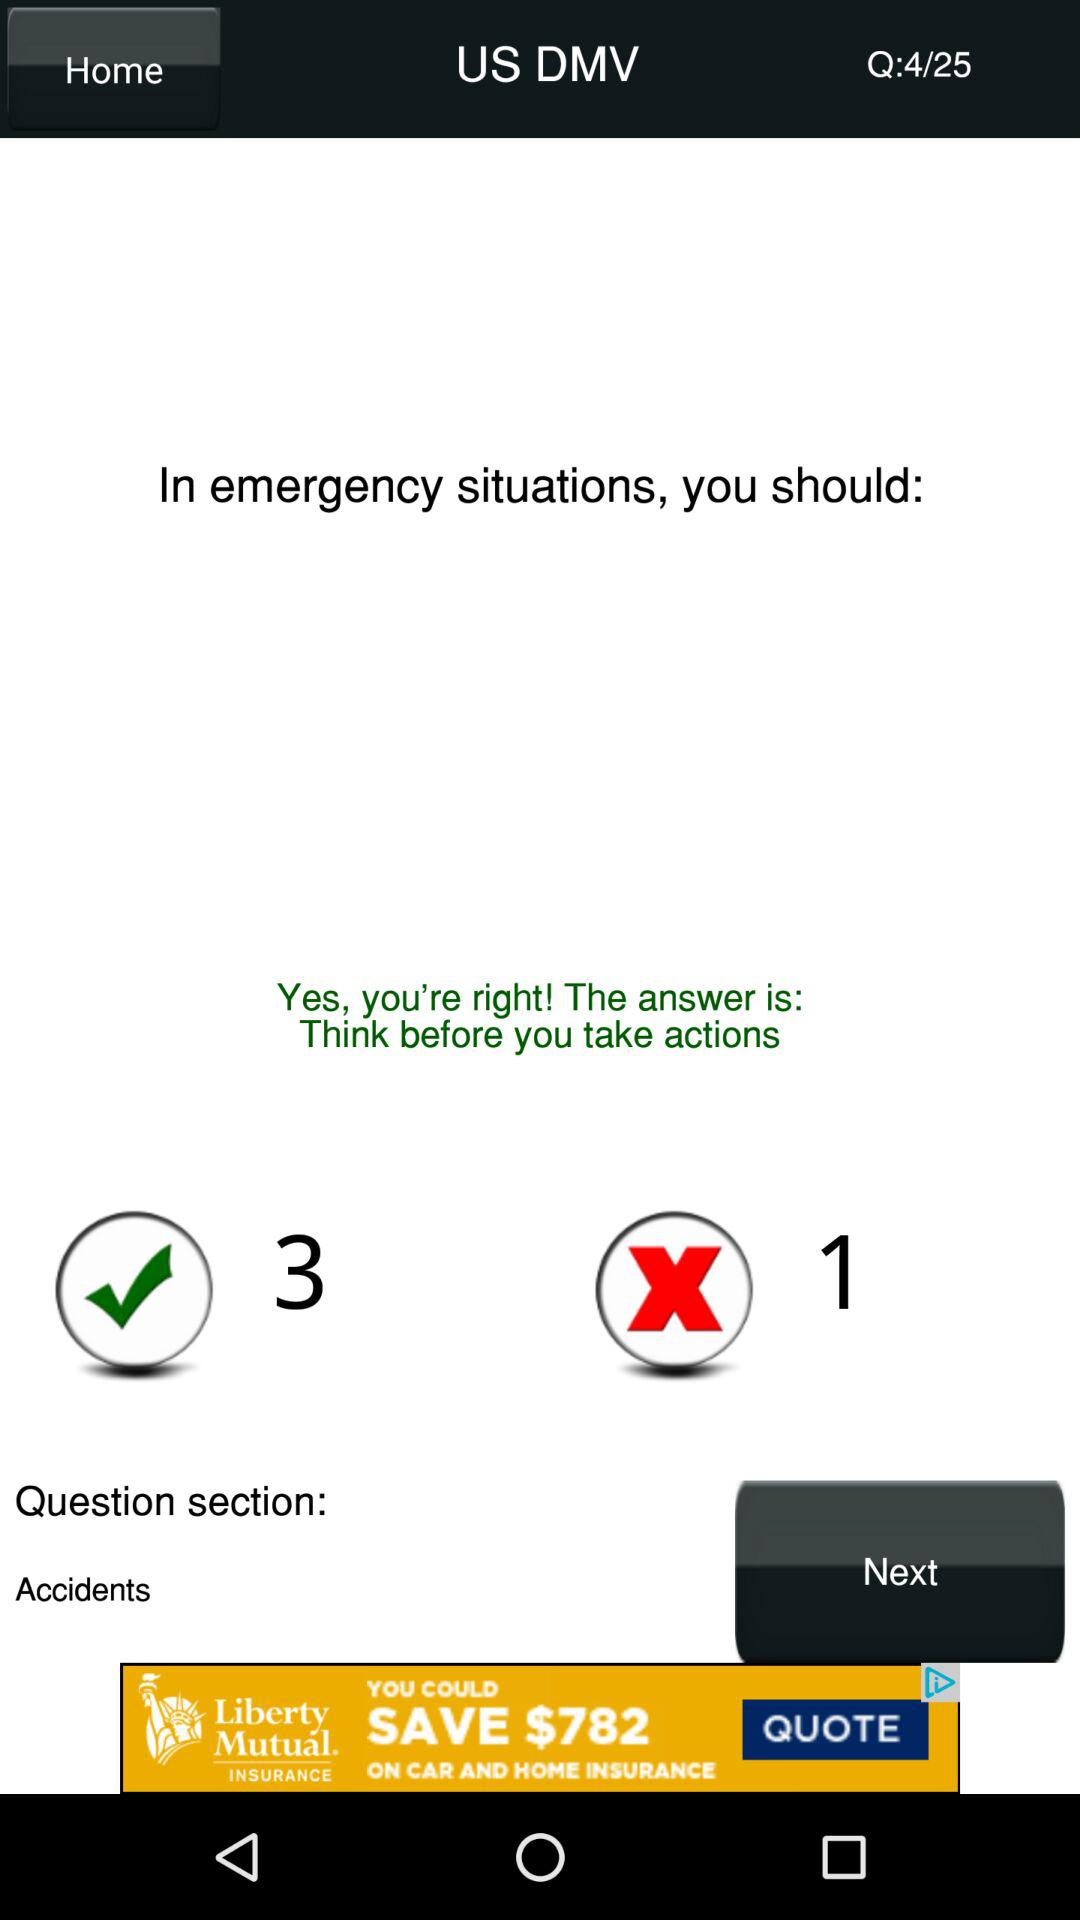How many more correct answers does the user have than incorrect answers?
Answer the question using a single word or phrase. 2 